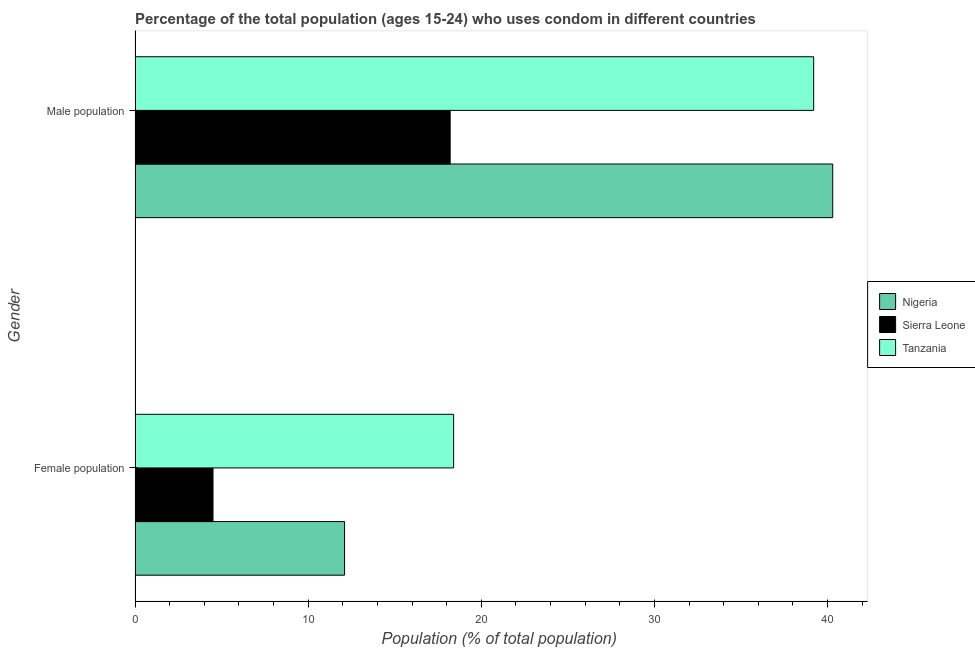Are the number of bars per tick equal to the number of legend labels?
Keep it short and to the point. Yes. Are the number of bars on each tick of the Y-axis equal?
Provide a short and direct response. Yes. How many bars are there on the 2nd tick from the bottom?
Ensure brevity in your answer.  3. What is the label of the 2nd group of bars from the top?
Keep it short and to the point. Female population. Across all countries, what is the maximum female population?
Provide a short and direct response. 18.4. In which country was the male population maximum?
Provide a short and direct response. Nigeria. In which country was the male population minimum?
Your answer should be compact. Sierra Leone. What is the total female population in the graph?
Ensure brevity in your answer.  35. What is the difference between the female population in Nigeria and that in Tanzania?
Offer a very short reply. -6.3. What is the difference between the male population in Sierra Leone and the female population in Tanzania?
Provide a short and direct response. -0.2. What is the average female population per country?
Offer a very short reply. 11.67. What is the difference between the female population and male population in Tanzania?
Offer a terse response. -20.8. What is the ratio of the female population in Sierra Leone to that in Nigeria?
Your response must be concise. 0.37. Is the female population in Tanzania less than that in Sierra Leone?
Offer a very short reply. No. In how many countries, is the female population greater than the average female population taken over all countries?
Offer a very short reply. 2. What does the 2nd bar from the top in Male population represents?
Keep it short and to the point. Sierra Leone. What does the 1st bar from the bottom in Male population represents?
Offer a terse response. Nigeria. How many bars are there?
Your answer should be very brief. 6. What is the difference between two consecutive major ticks on the X-axis?
Offer a terse response. 10. Are the values on the major ticks of X-axis written in scientific E-notation?
Your response must be concise. No. How many legend labels are there?
Keep it short and to the point. 3. How are the legend labels stacked?
Your answer should be compact. Vertical. What is the title of the graph?
Give a very brief answer. Percentage of the total population (ages 15-24) who uses condom in different countries. What is the label or title of the X-axis?
Provide a short and direct response. Population (% of total population) . What is the Population (% of total population)  of Nigeria in Male population?
Provide a succinct answer. 40.3. What is the Population (% of total population)  of Tanzania in Male population?
Give a very brief answer. 39.2. Across all Gender, what is the maximum Population (% of total population)  in Nigeria?
Ensure brevity in your answer.  40.3. Across all Gender, what is the maximum Population (% of total population)  of Sierra Leone?
Make the answer very short. 18.2. Across all Gender, what is the maximum Population (% of total population)  of Tanzania?
Keep it short and to the point. 39.2. Across all Gender, what is the minimum Population (% of total population)  in Nigeria?
Your answer should be very brief. 12.1. Across all Gender, what is the minimum Population (% of total population)  of Sierra Leone?
Offer a very short reply. 4.5. What is the total Population (% of total population)  in Nigeria in the graph?
Keep it short and to the point. 52.4. What is the total Population (% of total population)  in Sierra Leone in the graph?
Provide a succinct answer. 22.7. What is the total Population (% of total population)  in Tanzania in the graph?
Provide a succinct answer. 57.6. What is the difference between the Population (% of total population)  in Nigeria in Female population and that in Male population?
Your response must be concise. -28.2. What is the difference between the Population (% of total population)  of Sierra Leone in Female population and that in Male population?
Give a very brief answer. -13.7. What is the difference between the Population (% of total population)  in Tanzania in Female population and that in Male population?
Provide a succinct answer. -20.8. What is the difference between the Population (% of total population)  of Nigeria in Female population and the Population (% of total population)  of Sierra Leone in Male population?
Provide a short and direct response. -6.1. What is the difference between the Population (% of total population)  in Nigeria in Female population and the Population (% of total population)  in Tanzania in Male population?
Offer a very short reply. -27.1. What is the difference between the Population (% of total population)  of Sierra Leone in Female population and the Population (% of total population)  of Tanzania in Male population?
Your answer should be very brief. -34.7. What is the average Population (% of total population)  of Nigeria per Gender?
Make the answer very short. 26.2. What is the average Population (% of total population)  of Sierra Leone per Gender?
Provide a succinct answer. 11.35. What is the average Population (% of total population)  of Tanzania per Gender?
Give a very brief answer. 28.8. What is the difference between the Population (% of total population)  in Nigeria and Population (% of total population)  in Sierra Leone in Male population?
Your answer should be compact. 22.1. What is the difference between the Population (% of total population)  of Sierra Leone and Population (% of total population)  of Tanzania in Male population?
Provide a short and direct response. -21. What is the ratio of the Population (% of total population)  of Nigeria in Female population to that in Male population?
Provide a short and direct response. 0.3. What is the ratio of the Population (% of total population)  in Sierra Leone in Female population to that in Male population?
Provide a short and direct response. 0.25. What is the ratio of the Population (% of total population)  in Tanzania in Female population to that in Male population?
Make the answer very short. 0.47. What is the difference between the highest and the second highest Population (% of total population)  of Nigeria?
Keep it short and to the point. 28.2. What is the difference between the highest and the second highest Population (% of total population)  in Sierra Leone?
Your answer should be very brief. 13.7. What is the difference between the highest and the second highest Population (% of total population)  of Tanzania?
Your answer should be compact. 20.8. What is the difference between the highest and the lowest Population (% of total population)  of Nigeria?
Your response must be concise. 28.2. What is the difference between the highest and the lowest Population (% of total population)  in Sierra Leone?
Offer a very short reply. 13.7. What is the difference between the highest and the lowest Population (% of total population)  in Tanzania?
Provide a short and direct response. 20.8. 